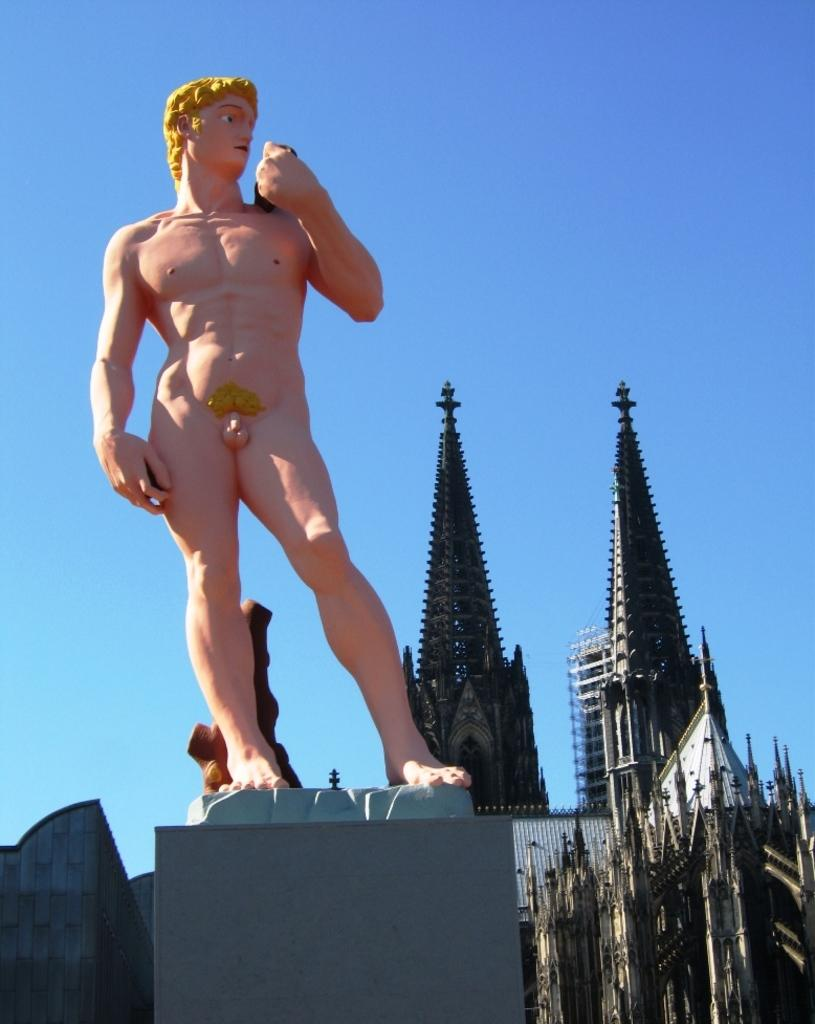What is the main subject of the image? There is a nude statue of a person on a platform in the image. What can be seen in the background of the image? There are buildings in the background of the image. What color is the sky in the image? The sky is blue in the image. How many rabbits are hopping around the statue in the image? There are no rabbits present in the image. What letter is written on the statue in the image? There is no letter written on the statue in the image. 